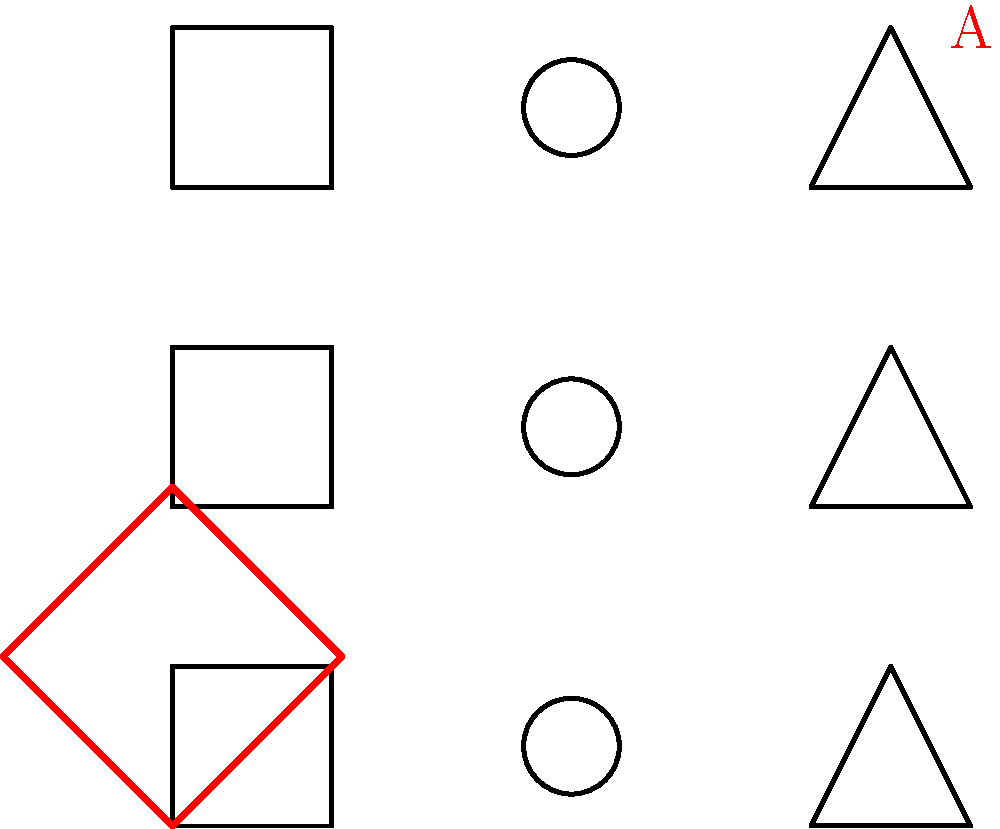In the diagram, traditional South Asian wedding attire patterns are shown in black. If pattern A is created by rotating one of these patterns, which original pattern was used and by how many degrees was it rotated? To solve this problem, we need to analyze the given patterns and the rotated pattern A:

1. Observe the three original patterns:
   - Square
   - Circle
   - Triangle

2. Compare pattern A (in red) with the original patterns:
   - Pattern A is a square shape
   - It's larger than the original patterns
   - It's rotated at an angle

3. Identify the original pattern:
   - Pattern A is clearly derived from the square pattern

4. Determine the rotation angle:
   - The original square has sides parallel to the x and y axes
   - Pattern A has its corners pointing to the x and y axes
   - This indicates a 45-degree rotation

5. Confirm the transformation:
   - A 45-degree rotation of the original square pattern would indeed produce pattern A

Therefore, pattern A was created by rotating the square pattern by 45 degrees and scaling it up.
Answer: Square pattern, 45 degrees 